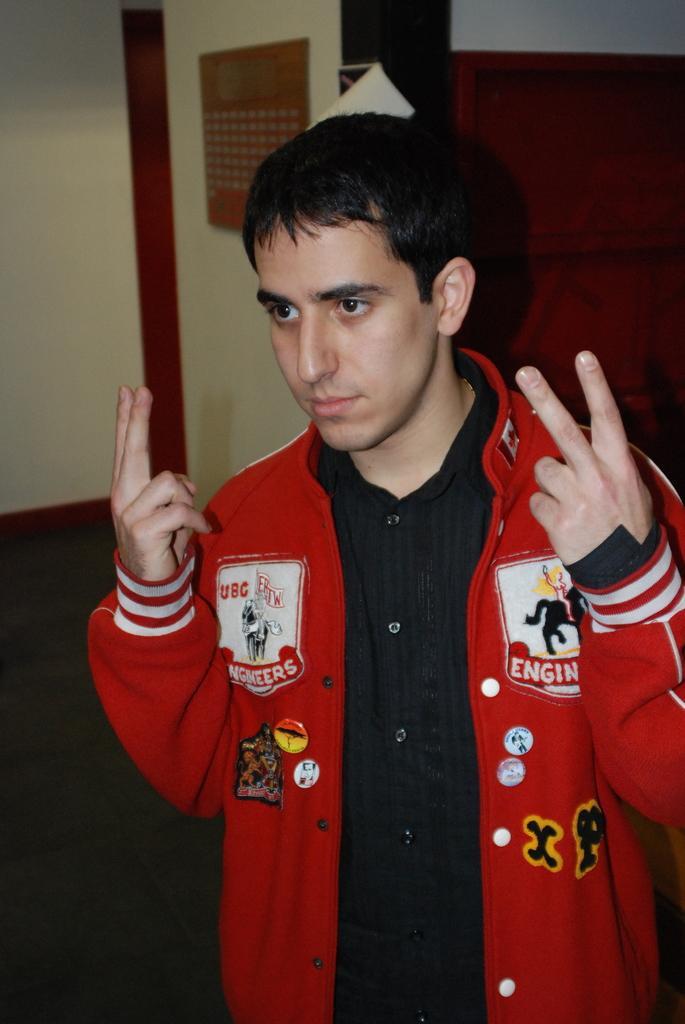In one or two sentences, can you explain what this image depicts? In this picture there is a boy wearing red color jacket, standing in the front and giving a pose to the camera. Behind there is a yellow color wall. 